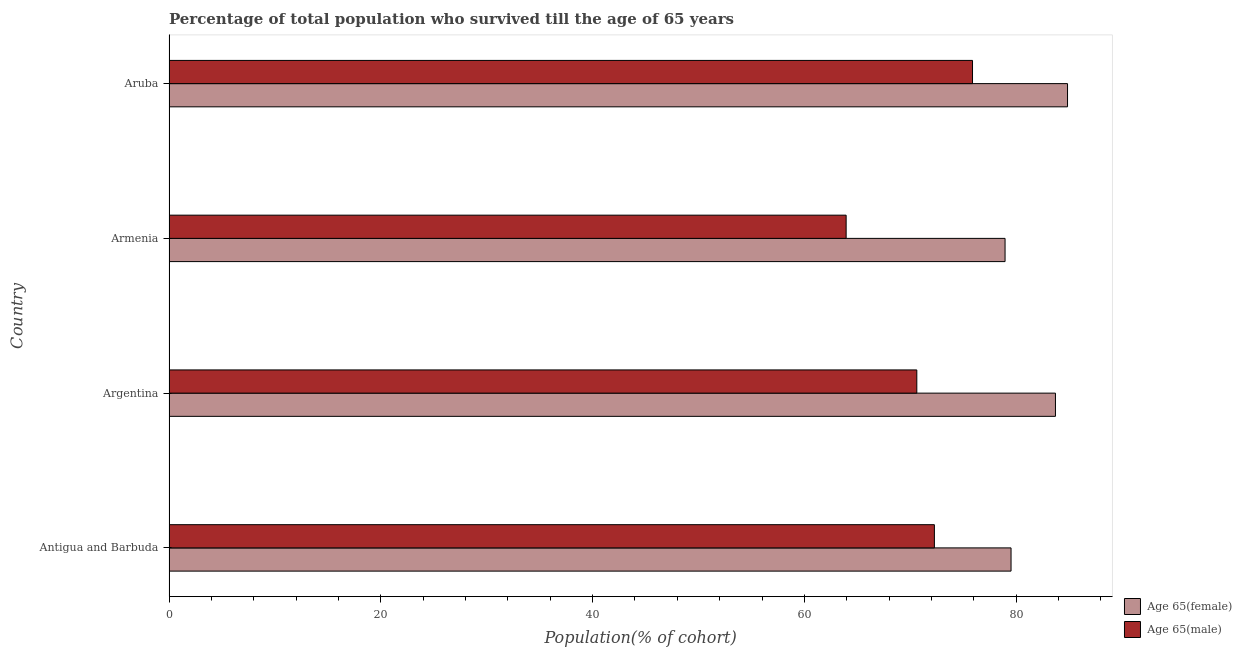Are the number of bars per tick equal to the number of legend labels?
Make the answer very short. Yes. How many bars are there on the 3rd tick from the bottom?
Keep it short and to the point. 2. What is the label of the 4th group of bars from the top?
Offer a terse response. Antigua and Barbuda. What is the percentage of male population who survived till age of 65 in Argentina?
Provide a short and direct response. 70.62. Across all countries, what is the maximum percentage of male population who survived till age of 65?
Offer a terse response. 75.88. Across all countries, what is the minimum percentage of female population who survived till age of 65?
Your answer should be very brief. 78.95. In which country was the percentage of male population who survived till age of 65 maximum?
Ensure brevity in your answer.  Aruba. In which country was the percentage of male population who survived till age of 65 minimum?
Provide a short and direct response. Armenia. What is the total percentage of male population who survived till age of 65 in the graph?
Ensure brevity in your answer.  282.71. What is the difference between the percentage of female population who survived till age of 65 in Argentina and that in Armenia?
Provide a short and direct response. 4.76. What is the difference between the percentage of male population who survived till age of 65 in Antigua and Barbuda and the percentage of female population who survived till age of 65 in Aruba?
Your response must be concise. -12.57. What is the average percentage of male population who survived till age of 65 per country?
Your answer should be very brief. 70.68. What is the difference between the percentage of female population who survived till age of 65 and percentage of male population who survived till age of 65 in Aruba?
Your response must be concise. 8.97. In how many countries, is the percentage of male population who survived till age of 65 greater than 20 %?
Provide a short and direct response. 4. Is the percentage of male population who survived till age of 65 in Armenia less than that in Aruba?
Your response must be concise. Yes. Is the difference between the percentage of female population who survived till age of 65 in Antigua and Barbuda and Aruba greater than the difference between the percentage of male population who survived till age of 65 in Antigua and Barbuda and Aruba?
Ensure brevity in your answer.  No. What is the difference between the highest and the second highest percentage of female population who survived till age of 65?
Ensure brevity in your answer.  1.14. What is the difference between the highest and the lowest percentage of male population who survived till age of 65?
Your answer should be compact. 11.93. What does the 1st bar from the top in Antigua and Barbuda represents?
Offer a very short reply. Age 65(male). What does the 2nd bar from the bottom in Argentina represents?
Give a very brief answer. Age 65(male). How many bars are there?
Offer a very short reply. 8. What is the difference between two consecutive major ticks on the X-axis?
Your response must be concise. 20. Does the graph contain grids?
Offer a very short reply. No. How many legend labels are there?
Your answer should be compact. 2. How are the legend labels stacked?
Make the answer very short. Vertical. What is the title of the graph?
Your answer should be compact. Percentage of total population who survived till the age of 65 years. What is the label or title of the X-axis?
Your response must be concise. Population(% of cohort). What is the Population(% of cohort) of Age 65(female) in Antigua and Barbuda?
Give a very brief answer. 79.52. What is the Population(% of cohort) of Age 65(male) in Antigua and Barbuda?
Your answer should be very brief. 72.28. What is the Population(% of cohort) in Age 65(female) in Argentina?
Offer a terse response. 83.71. What is the Population(% of cohort) in Age 65(male) in Argentina?
Make the answer very short. 70.62. What is the Population(% of cohort) of Age 65(female) in Armenia?
Make the answer very short. 78.95. What is the Population(% of cohort) of Age 65(male) in Armenia?
Offer a terse response. 63.94. What is the Population(% of cohort) in Age 65(female) in Aruba?
Ensure brevity in your answer.  84.85. What is the Population(% of cohort) of Age 65(male) in Aruba?
Ensure brevity in your answer.  75.88. Across all countries, what is the maximum Population(% of cohort) in Age 65(female)?
Your answer should be very brief. 84.85. Across all countries, what is the maximum Population(% of cohort) in Age 65(male)?
Give a very brief answer. 75.88. Across all countries, what is the minimum Population(% of cohort) in Age 65(female)?
Provide a succinct answer. 78.95. Across all countries, what is the minimum Population(% of cohort) in Age 65(male)?
Offer a very short reply. 63.94. What is the total Population(% of cohort) of Age 65(female) in the graph?
Your answer should be compact. 327.02. What is the total Population(% of cohort) of Age 65(male) in the graph?
Give a very brief answer. 282.71. What is the difference between the Population(% of cohort) of Age 65(female) in Antigua and Barbuda and that in Argentina?
Give a very brief answer. -4.19. What is the difference between the Population(% of cohort) in Age 65(male) in Antigua and Barbuda and that in Argentina?
Offer a terse response. 1.66. What is the difference between the Population(% of cohort) in Age 65(female) in Antigua and Barbuda and that in Armenia?
Your answer should be very brief. 0.56. What is the difference between the Population(% of cohort) in Age 65(male) in Antigua and Barbuda and that in Armenia?
Offer a very short reply. 8.33. What is the difference between the Population(% of cohort) in Age 65(female) in Antigua and Barbuda and that in Aruba?
Keep it short and to the point. -5.33. What is the difference between the Population(% of cohort) of Age 65(male) in Antigua and Barbuda and that in Aruba?
Your answer should be compact. -3.6. What is the difference between the Population(% of cohort) in Age 65(female) in Argentina and that in Armenia?
Your response must be concise. 4.76. What is the difference between the Population(% of cohort) in Age 65(male) in Argentina and that in Armenia?
Provide a short and direct response. 6.67. What is the difference between the Population(% of cohort) in Age 65(female) in Argentina and that in Aruba?
Make the answer very short. -1.14. What is the difference between the Population(% of cohort) in Age 65(male) in Argentina and that in Aruba?
Provide a succinct answer. -5.26. What is the difference between the Population(% of cohort) in Age 65(female) in Armenia and that in Aruba?
Provide a succinct answer. -5.9. What is the difference between the Population(% of cohort) of Age 65(male) in Armenia and that in Aruba?
Keep it short and to the point. -11.93. What is the difference between the Population(% of cohort) in Age 65(female) in Antigua and Barbuda and the Population(% of cohort) in Age 65(male) in Argentina?
Your response must be concise. 8.9. What is the difference between the Population(% of cohort) in Age 65(female) in Antigua and Barbuda and the Population(% of cohort) in Age 65(male) in Armenia?
Give a very brief answer. 15.57. What is the difference between the Population(% of cohort) in Age 65(female) in Antigua and Barbuda and the Population(% of cohort) in Age 65(male) in Aruba?
Your answer should be compact. 3.64. What is the difference between the Population(% of cohort) of Age 65(female) in Argentina and the Population(% of cohort) of Age 65(male) in Armenia?
Provide a succinct answer. 19.77. What is the difference between the Population(% of cohort) of Age 65(female) in Argentina and the Population(% of cohort) of Age 65(male) in Aruba?
Offer a very short reply. 7.83. What is the difference between the Population(% of cohort) of Age 65(female) in Armenia and the Population(% of cohort) of Age 65(male) in Aruba?
Offer a terse response. 3.07. What is the average Population(% of cohort) in Age 65(female) per country?
Provide a short and direct response. 81.76. What is the average Population(% of cohort) of Age 65(male) per country?
Provide a succinct answer. 70.68. What is the difference between the Population(% of cohort) in Age 65(female) and Population(% of cohort) in Age 65(male) in Antigua and Barbuda?
Your answer should be very brief. 7.24. What is the difference between the Population(% of cohort) in Age 65(female) and Population(% of cohort) in Age 65(male) in Argentina?
Provide a short and direct response. 13.09. What is the difference between the Population(% of cohort) of Age 65(female) and Population(% of cohort) of Age 65(male) in Armenia?
Your answer should be very brief. 15.01. What is the difference between the Population(% of cohort) in Age 65(female) and Population(% of cohort) in Age 65(male) in Aruba?
Your answer should be very brief. 8.97. What is the ratio of the Population(% of cohort) of Age 65(female) in Antigua and Barbuda to that in Argentina?
Offer a terse response. 0.95. What is the ratio of the Population(% of cohort) of Age 65(male) in Antigua and Barbuda to that in Argentina?
Make the answer very short. 1.02. What is the ratio of the Population(% of cohort) of Age 65(female) in Antigua and Barbuda to that in Armenia?
Your answer should be compact. 1.01. What is the ratio of the Population(% of cohort) in Age 65(male) in Antigua and Barbuda to that in Armenia?
Your answer should be compact. 1.13. What is the ratio of the Population(% of cohort) of Age 65(female) in Antigua and Barbuda to that in Aruba?
Your answer should be very brief. 0.94. What is the ratio of the Population(% of cohort) of Age 65(male) in Antigua and Barbuda to that in Aruba?
Provide a short and direct response. 0.95. What is the ratio of the Population(% of cohort) in Age 65(female) in Argentina to that in Armenia?
Provide a succinct answer. 1.06. What is the ratio of the Population(% of cohort) of Age 65(male) in Argentina to that in Armenia?
Your answer should be very brief. 1.1. What is the ratio of the Population(% of cohort) of Age 65(female) in Argentina to that in Aruba?
Provide a short and direct response. 0.99. What is the ratio of the Population(% of cohort) in Age 65(male) in Argentina to that in Aruba?
Provide a short and direct response. 0.93. What is the ratio of the Population(% of cohort) of Age 65(female) in Armenia to that in Aruba?
Provide a succinct answer. 0.93. What is the ratio of the Population(% of cohort) in Age 65(male) in Armenia to that in Aruba?
Ensure brevity in your answer.  0.84. What is the difference between the highest and the second highest Population(% of cohort) in Age 65(female)?
Give a very brief answer. 1.14. What is the difference between the highest and the second highest Population(% of cohort) of Age 65(male)?
Offer a terse response. 3.6. What is the difference between the highest and the lowest Population(% of cohort) of Age 65(female)?
Ensure brevity in your answer.  5.9. What is the difference between the highest and the lowest Population(% of cohort) in Age 65(male)?
Keep it short and to the point. 11.93. 